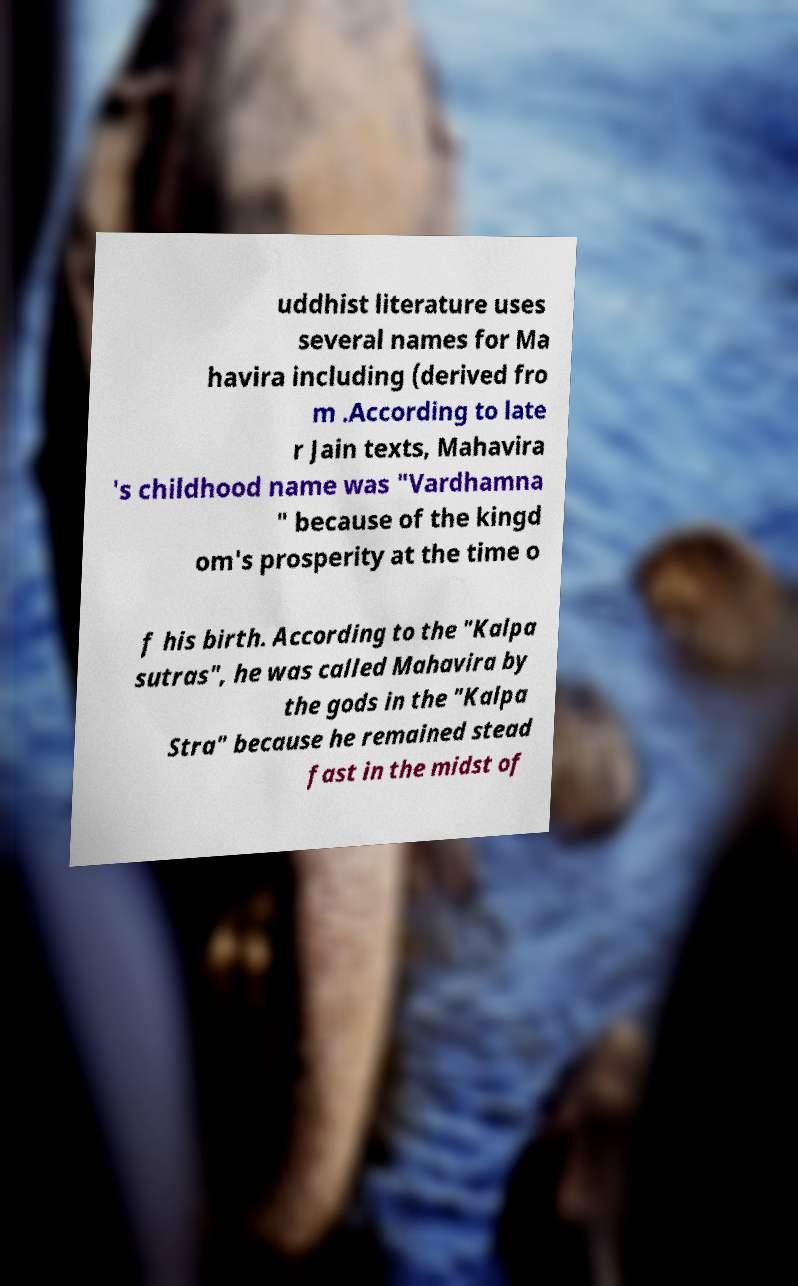Please read and relay the text visible in this image. What does it say? uddhist literature uses several names for Ma havira including (derived fro m .According to late r Jain texts, Mahavira 's childhood name was "Vardhamna " because of the kingd om's prosperity at the time o f his birth. According to the "Kalpa sutras", he was called Mahavira by the gods in the "Kalpa Stra" because he remained stead fast in the midst of 